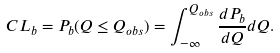Convert formula to latex. <formula><loc_0><loc_0><loc_500><loc_500>C L _ { b } = P _ { b } ( Q \leq Q _ { o b s } ) = \int ^ { Q _ { o b s } } _ { - \infty } \frac { d P _ { b } } { d Q } d Q .</formula> 